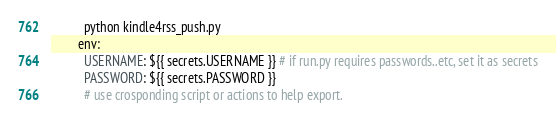<code> <loc_0><loc_0><loc_500><loc_500><_YAML_>          python kindle4rss_push.py
        env:
          USERNAME: ${{ secrets.USERNAME }} # if run.py requires passwords..etc, set it as secrets
          PASSWORD: ${{ secrets.PASSWORD }}
          # use crosponding script or actions to help export.
</code> 